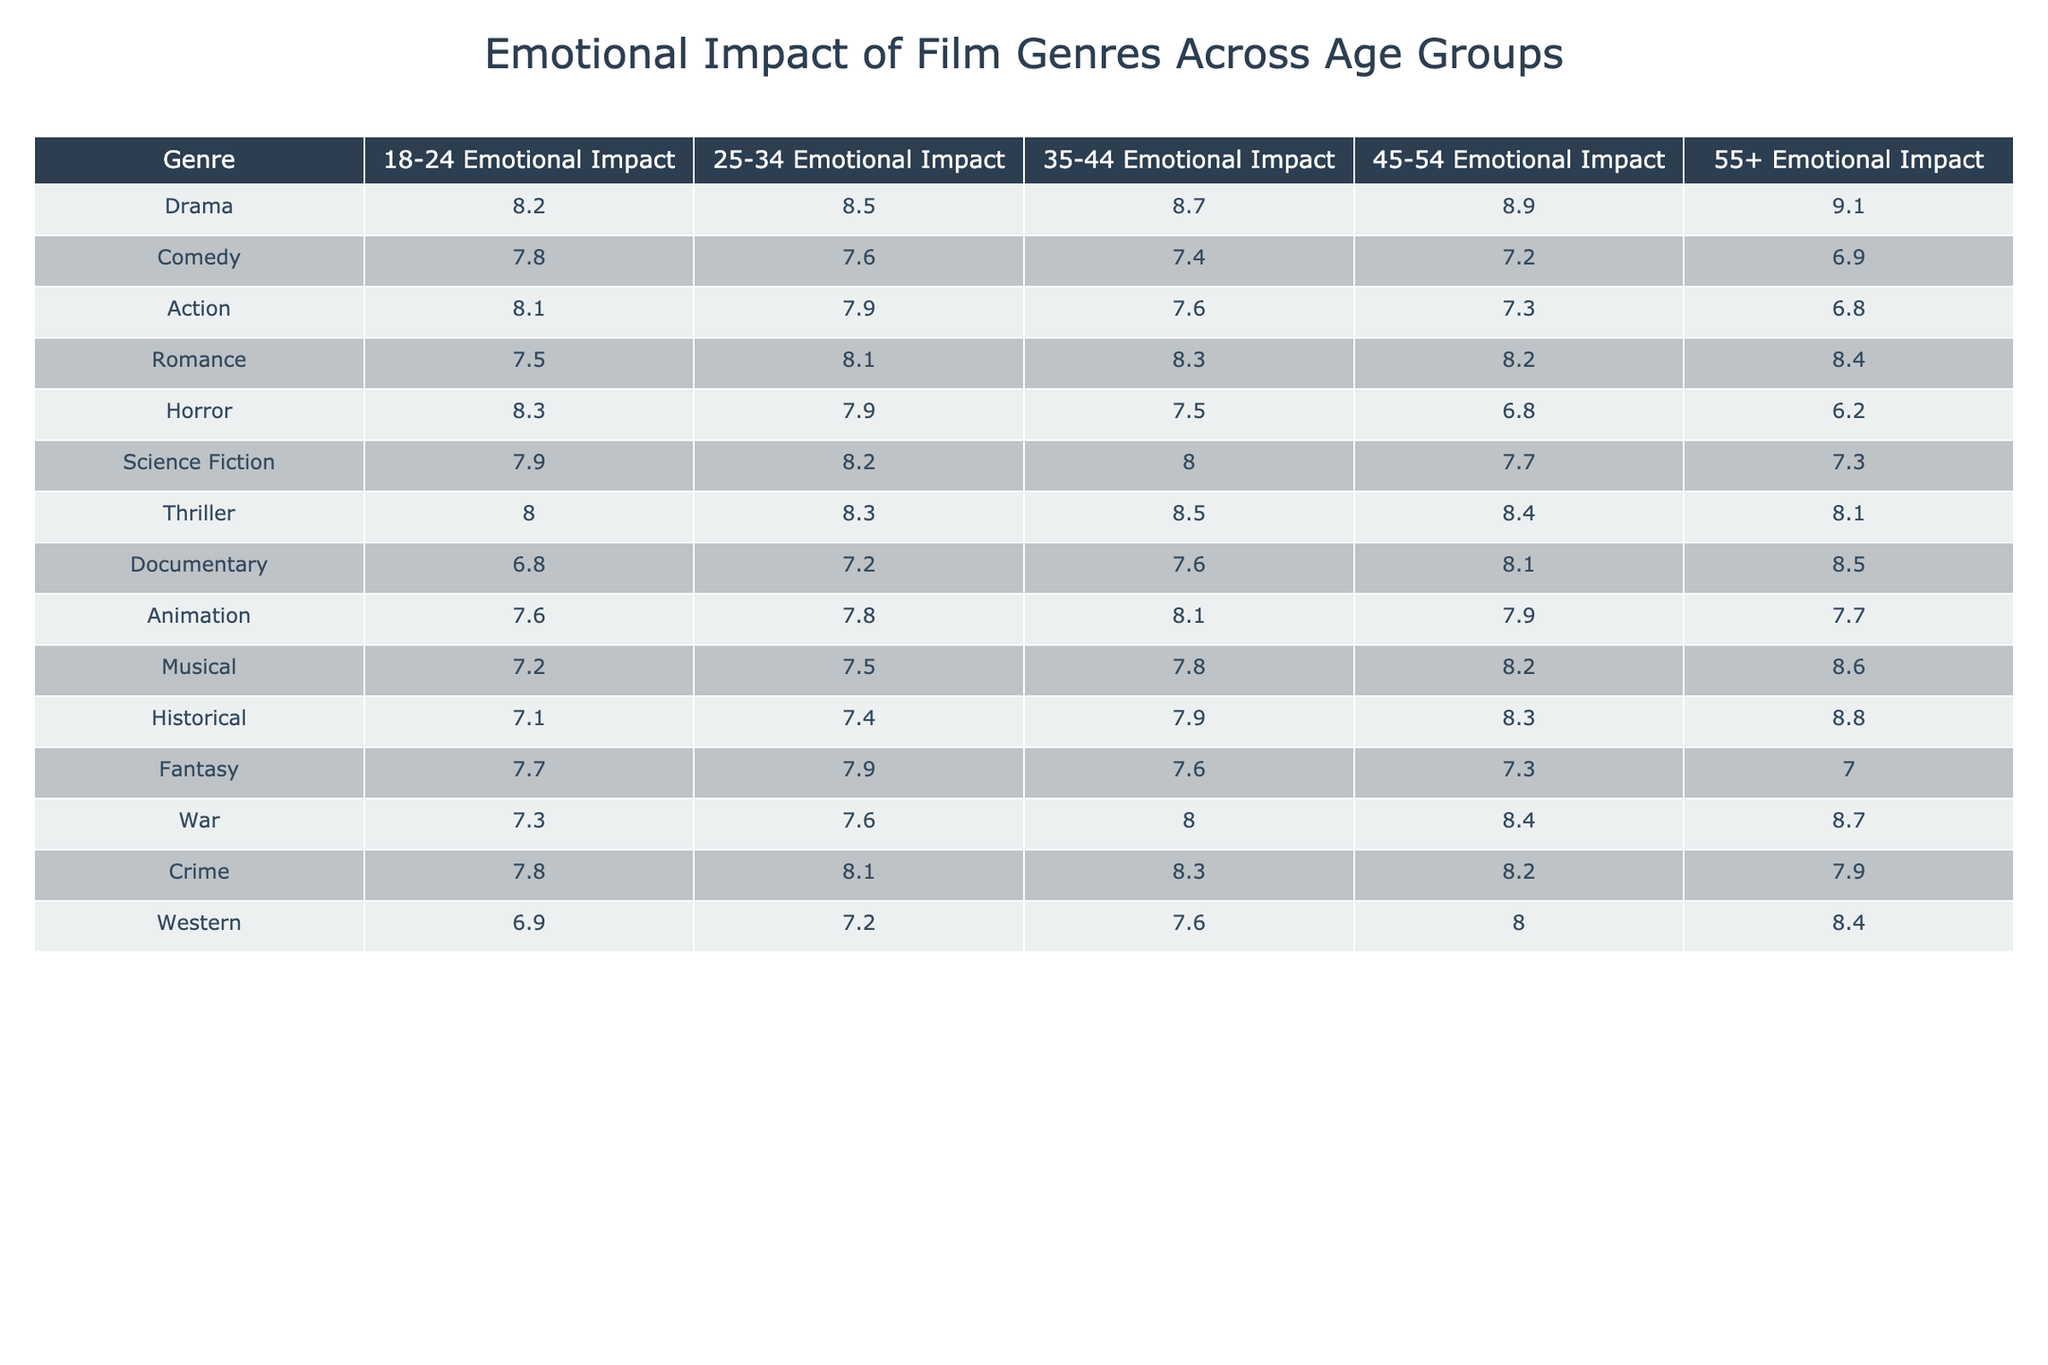What is the emotional impact rating for Action films in the 35-44 age group? Looking at the table, under the Action genre, the emotional impact rating for the 35-44 age group is listed as 7.6.
Answer: 7.6 Which genre has the highest emotional impact rating in the 55+ age group? In the table, when comparing the emotional impact ratings for the 55+ age group, Drama has the highest rating at 9.1.
Answer: Drama What is the difference in emotional impact ratings between Horror and Comedy for the 18-24 age group? For the 18-24 age group, Horror has a rating of 8.3 and Comedy has a rating of 7.8. The difference is 8.3 - 7.8 = 0.5.
Answer: 0.5 What is the average emotional impact rating for the Romance genre across all age groups? To find the average for Romance, we sum up the ratings for each age group: (7.5 + 8.1 + 8.3 + 8.2 + 8.4) = 40.5. Dividing by the number of age groups (5), we get 40.5 / 5 = 8.1.
Answer: 8.1 Is the emotional impact rating for Western films higher than that of Documentary films for the 25-34 age group? In the 25-34 age group, the emotional impact rating for Western is 7.2 while for Documentary it is 7.2 as well. Therefore, they are equal, and neither is higher.
Answer: No Which film genre has the lowest emotional impact rating in the 45-54 age group? By reviewing the 45-54 age group ratings, Horror has the lowest rating at 6.8 compared to the other genres listed.
Answer: Horror What is the emotional impact rating trend for Animation films across age groups? For Animation, the ratings are: 18-24 (7.6), 25-34 (7.8), 35-44 (8.1), 45-54 (7.9), and 55+ (7.7). The trend shows an increase from 18-24 to 35-44 and then a slight decrease in the last two age groups.
Answer: Increases then decreases Which genre has a consistently high emotional impact across all age groups? Examining the table, Drama shows a consistently high emotional impact rating with values (8.2, 8.5, 8.7, 8.9, 9.1) across all the age groups.
Answer: Drama What is the emotional impact rating for Crime films across all age groups? For Crime, the emotional impact ratings are: 18-24 (7.8), 25-34 (8.1), 35-44 (8.3), 45-54 (8.2), and 55+ (7.9). The values are easily readable in the table.
Answer: 7.8, 8.1, 8.3, 8.2, 7.9 Is there any age group where the emotional impact rating for Musicals is the highest compared to other genres? Analyzing the table, in the 55+ age group, Musical has a rating of 8.6, which is higher than most other genres, but Drama at 9.1 is still higher. Thus, Musicals do not have the highest rating in any age group.
Answer: No 